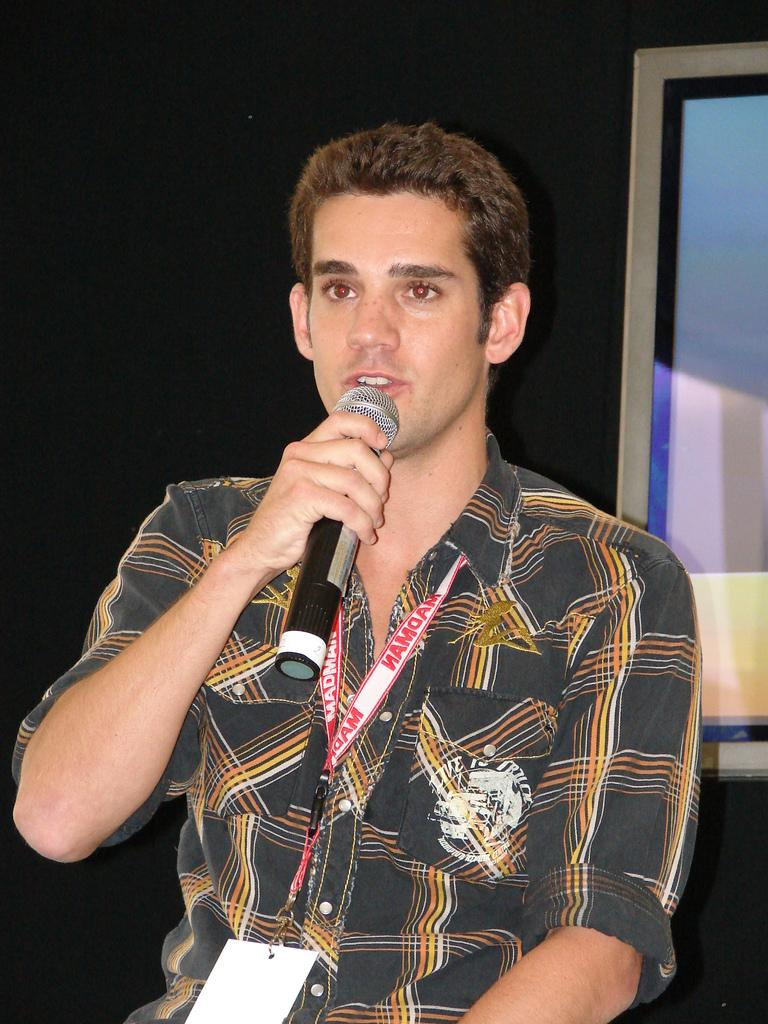What can be seen in the image? There is a person in the image. What is the person wearing? The person is wearing an ID card. What is the person holding in his hand? The person is holding a mic in his hand. What object is on the right side of the image? There is a photo frame on the right side of the image. What type of owl can be seen in the image? There is no owl present in the image. Is the person wearing any underwear in the image? The provided facts do not mention anything about the person's underwear, so it cannot be determined from the image. 